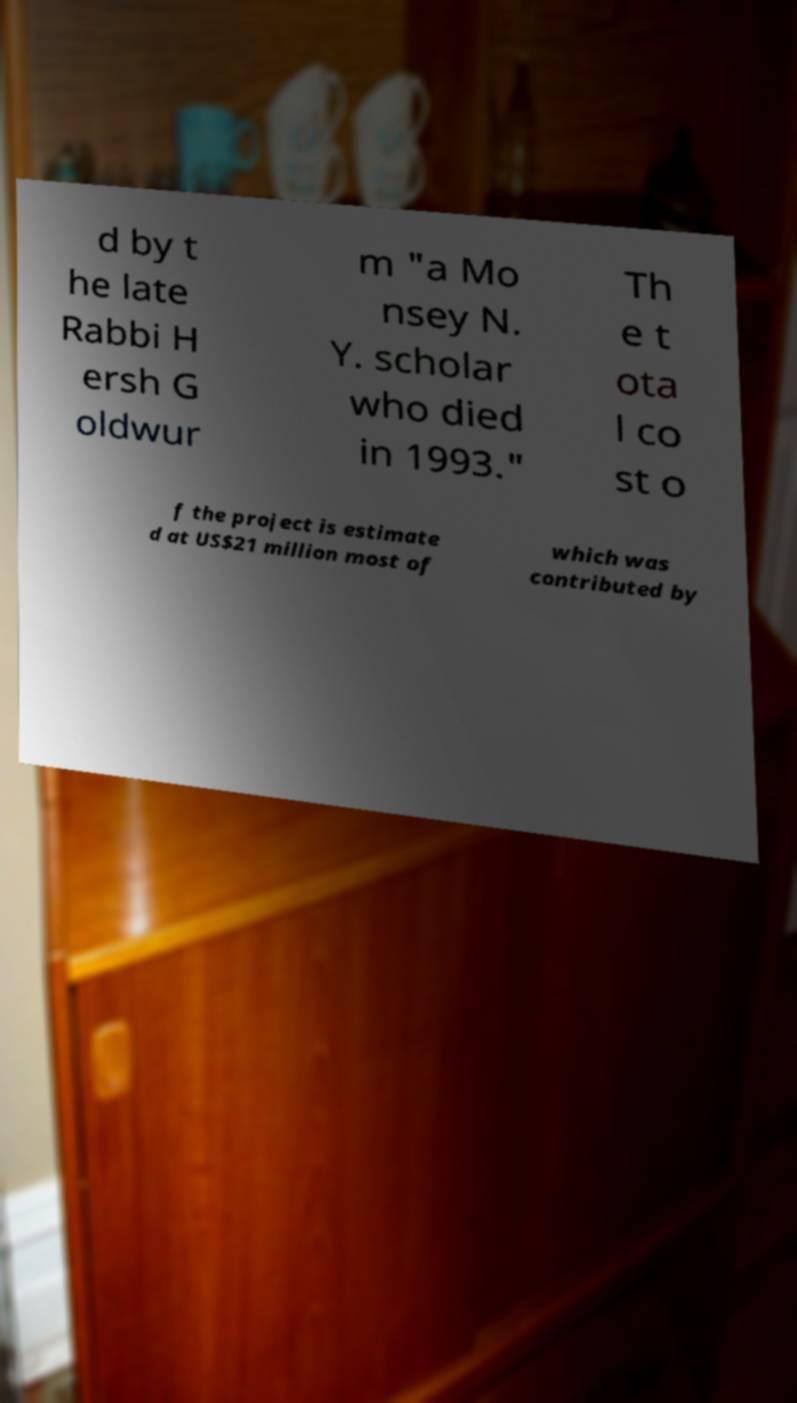Please identify and transcribe the text found in this image. d by t he late Rabbi H ersh G oldwur m "a Mo nsey N. Y. scholar who died in 1993." Th e t ota l co st o f the project is estimate d at US$21 million most of which was contributed by 